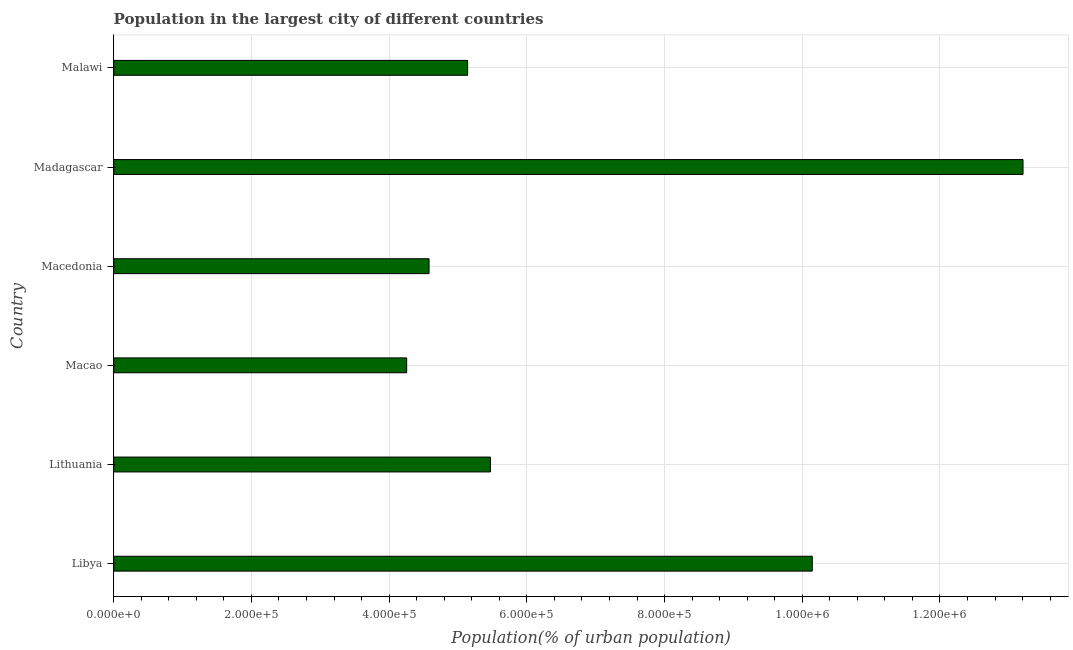Does the graph contain any zero values?
Your answer should be very brief. No. What is the title of the graph?
Offer a terse response. Population in the largest city of different countries. What is the label or title of the X-axis?
Offer a very short reply. Population(% of urban population). What is the label or title of the Y-axis?
Make the answer very short. Country. What is the population in largest city in Madagascar?
Provide a succinct answer. 1.32e+06. Across all countries, what is the maximum population in largest city?
Give a very brief answer. 1.32e+06. Across all countries, what is the minimum population in largest city?
Your answer should be compact. 4.25e+05. In which country was the population in largest city maximum?
Give a very brief answer. Madagascar. In which country was the population in largest city minimum?
Your answer should be very brief. Macao. What is the sum of the population in largest city?
Your answer should be compact. 4.28e+06. What is the difference between the population in largest city in Libya and Malawi?
Your response must be concise. 5.01e+05. What is the average population in largest city per country?
Give a very brief answer. 7.13e+05. What is the median population in largest city?
Your answer should be very brief. 5.31e+05. In how many countries, is the population in largest city greater than 1000000 %?
Provide a short and direct response. 2. What is the ratio of the population in largest city in Libya to that in Malawi?
Provide a short and direct response. 1.97. Is the population in largest city in Macao less than that in Madagascar?
Ensure brevity in your answer.  Yes. Is the difference between the population in largest city in Lithuania and Macedonia greater than the difference between any two countries?
Offer a very short reply. No. What is the difference between the highest and the second highest population in largest city?
Give a very brief answer. 3.06e+05. Is the sum of the population in largest city in Macao and Macedonia greater than the maximum population in largest city across all countries?
Provide a short and direct response. No. What is the difference between the highest and the lowest population in largest city?
Offer a terse response. 8.95e+05. In how many countries, is the population in largest city greater than the average population in largest city taken over all countries?
Keep it short and to the point. 2. Are the values on the major ticks of X-axis written in scientific E-notation?
Your answer should be compact. Yes. What is the Population(% of urban population) of Libya?
Provide a succinct answer. 1.01e+06. What is the Population(% of urban population) in Lithuania?
Your answer should be compact. 5.47e+05. What is the Population(% of urban population) of Macao?
Offer a terse response. 4.25e+05. What is the Population(% of urban population) of Macedonia?
Ensure brevity in your answer.  4.58e+05. What is the Population(% of urban population) in Madagascar?
Ensure brevity in your answer.  1.32e+06. What is the Population(% of urban population) of Malawi?
Make the answer very short. 5.14e+05. What is the difference between the Population(% of urban population) in Libya and Lithuania?
Provide a succinct answer. 4.67e+05. What is the difference between the Population(% of urban population) in Libya and Macao?
Give a very brief answer. 5.89e+05. What is the difference between the Population(% of urban population) in Libya and Macedonia?
Offer a very short reply. 5.57e+05. What is the difference between the Population(% of urban population) in Libya and Madagascar?
Offer a terse response. -3.06e+05. What is the difference between the Population(% of urban population) in Libya and Malawi?
Your response must be concise. 5.01e+05. What is the difference between the Population(% of urban population) in Lithuania and Macao?
Provide a short and direct response. 1.22e+05. What is the difference between the Population(% of urban population) in Lithuania and Macedonia?
Make the answer very short. 8.92e+04. What is the difference between the Population(% of urban population) in Lithuania and Madagascar?
Offer a very short reply. -7.74e+05. What is the difference between the Population(% of urban population) in Lithuania and Malawi?
Give a very brief answer. 3.32e+04. What is the difference between the Population(% of urban population) in Macao and Macedonia?
Ensure brevity in your answer.  -3.25e+04. What is the difference between the Population(% of urban population) in Macao and Madagascar?
Make the answer very short. -8.95e+05. What is the difference between the Population(% of urban population) in Macao and Malawi?
Your response must be concise. -8.85e+04. What is the difference between the Population(% of urban population) in Macedonia and Madagascar?
Ensure brevity in your answer.  -8.63e+05. What is the difference between the Population(% of urban population) in Macedonia and Malawi?
Your answer should be compact. -5.60e+04. What is the difference between the Population(% of urban population) in Madagascar and Malawi?
Give a very brief answer. 8.07e+05. What is the ratio of the Population(% of urban population) in Libya to that in Lithuania?
Make the answer very short. 1.85. What is the ratio of the Population(% of urban population) in Libya to that in Macao?
Your response must be concise. 2.38. What is the ratio of the Population(% of urban population) in Libya to that in Macedonia?
Your answer should be very brief. 2.21. What is the ratio of the Population(% of urban population) in Libya to that in Madagascar?
Ensure brevity in your answer.  0.77. What is the ratio of the Population(% of urban population) in Libya to that in Malawi?
Keep it short and to the point. 1.97. What is the ratio of the Population(% of urban population) in Lithuania to that in Macao?
Provide a short and direct response. 1.29. What is the ratio of the Population(% of urban population) in Lithuania to that in Macedonia?
Give a very brief answer. 1.2. What is the ratio of the Population(% of urban population) in Lithuania to that in Madagascar?
Your answer should be compact. 0.41. What is the ratio of the Population(% of urban population) in Lithuania to that in Malawi?
Your answer should be very brief. 1.06. What is the ratio of the Population(% of urban population) in Macao to that in Macedonia?
Ensure brevity in your answer.  0.93. What is the ratio of the Population(% of urban population) in Macao to that in Madagascar?
Offer a very short reply. 0.32. What is the ratio of the Population(% of urban population) in Macao to that in Malawi?
Make the answer very short. 0.83. What is the ratio of the Population(% of urban population) in Macedonia to that in Madagascar?
Your answer should be very brief. 0.35. What is the ratio of the Population(% of urban population) in Macedonia to that in Malawi?
Provide a succinct answer. 0.89. What is the ratio of the Population(% of urban population) in Madagascar to that in Malawi?
Your answer should be compact. 2.57. 